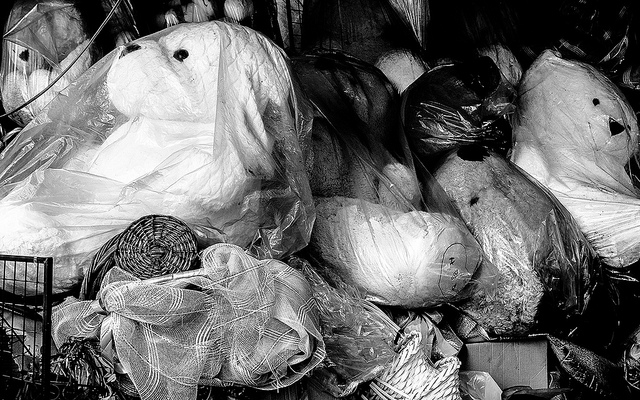What emotions might this image evoke? This image could evoke a sense of nostalgia or melancholy, as one might associate the huddled and wrapped items with forgotten memories or discarded possessions. For some, it might spark a sense of curiosity about the stories behind these items. Others may feel the clutter and disarray are sober reminders of overconsumption and the lifecycle of unwanted goods. 